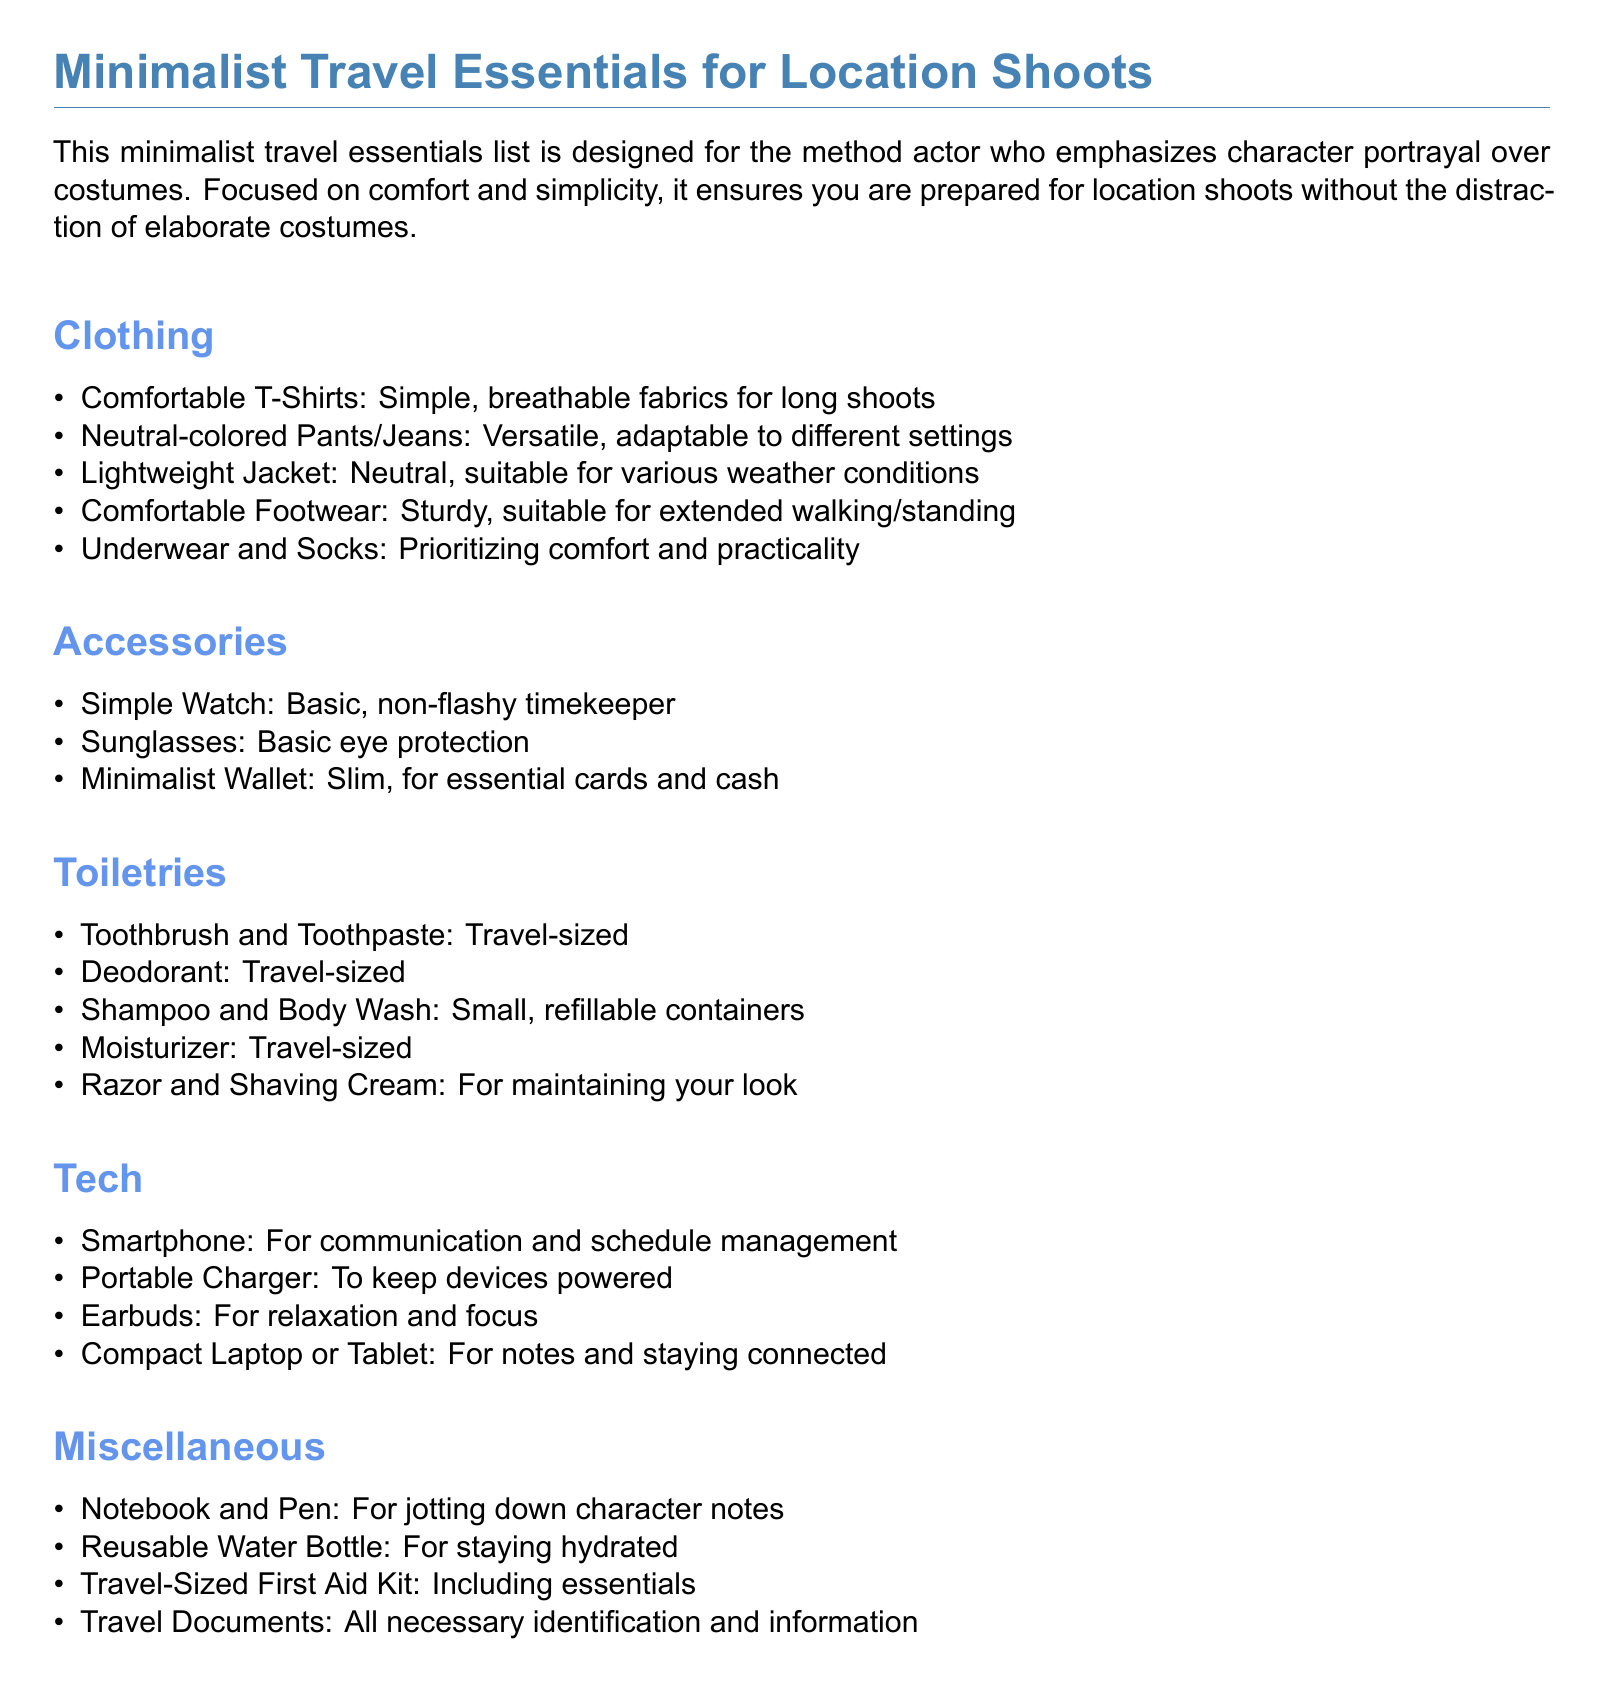What items are listed under clothing? The clothing section contains multiple items including T-Shirts, Pants/Jeans, Jacket, Footwear, Underwear, and Socks.
Answer: T-Shirts, Pants/Jeans, Jacket, Footwear, Underwear, Socks How many types of toiletries are mentioned? The toiletries category lists five specific items that focus on personal care during travel.
Answer: 5 What is a recommended type of footwear? The document suggests a specific type of footwear suitable for long durations, emphasizing comfort for the actor.
Answer: Comfortable Footwear What essential tech item is mentioned? The tech section includes items that help with communication and management during shoots, including a smartphone.
Answer: Smartphone What should be included in the miscellaneous category? The miscellaneous section includes diverse items necessary for travel, such as a notebook, water bottle, and others.
Answer: Notebook, Water Bottle, First Aid Kit, Travel Documents What type of wallet is suggested? The accessories section recommends a particular wallet type that is designed for minimalism and efficiency during travel.
Answer: Minimalist Wallet What is the purpose of packing a reusable water bottle? The document implies the importance of hydration during shoots, indicating that a reusable water bottle is essential for this purpose.
Answer: Staying hydrated How many items are listed in the accessories section? The accessories section items include three specific types that aid in convenience and practicality during travel.
Answer: 3 